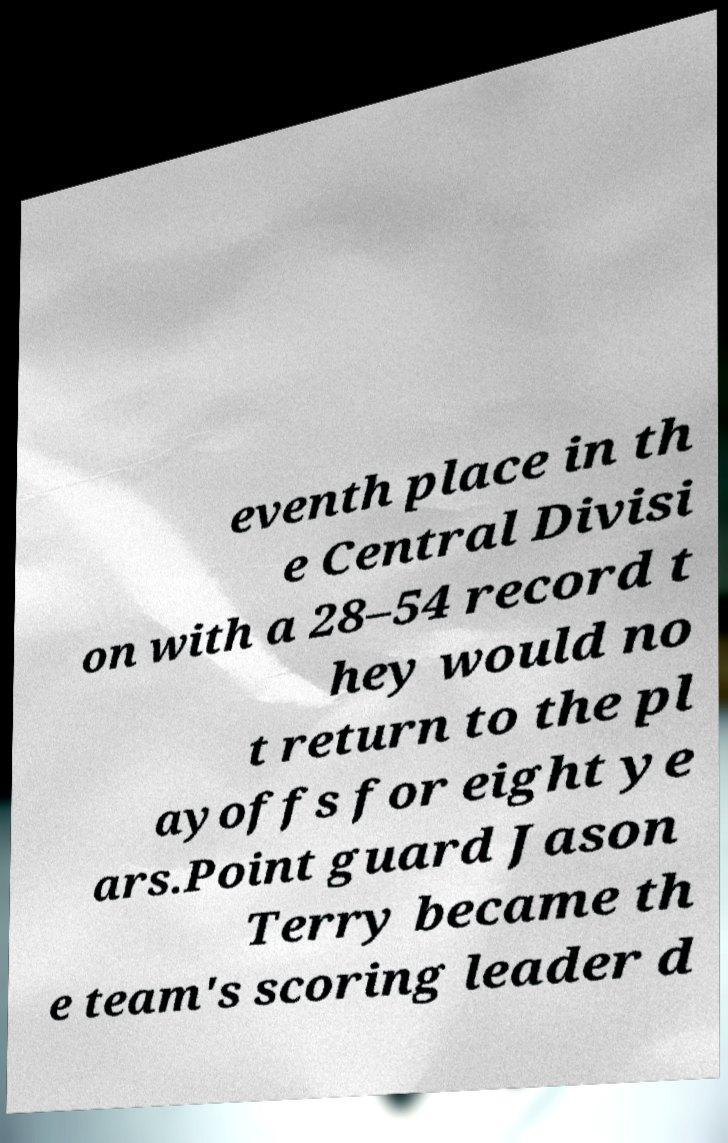What messages or text are displayed in this image? I need them in a readable, typed format. eventh place in th e Central Divisi on with a 28–54 record t hey would no t return to the pl ayoffs for eight ye ars.Point guard Jason Terry became th e team's scoring leader d 